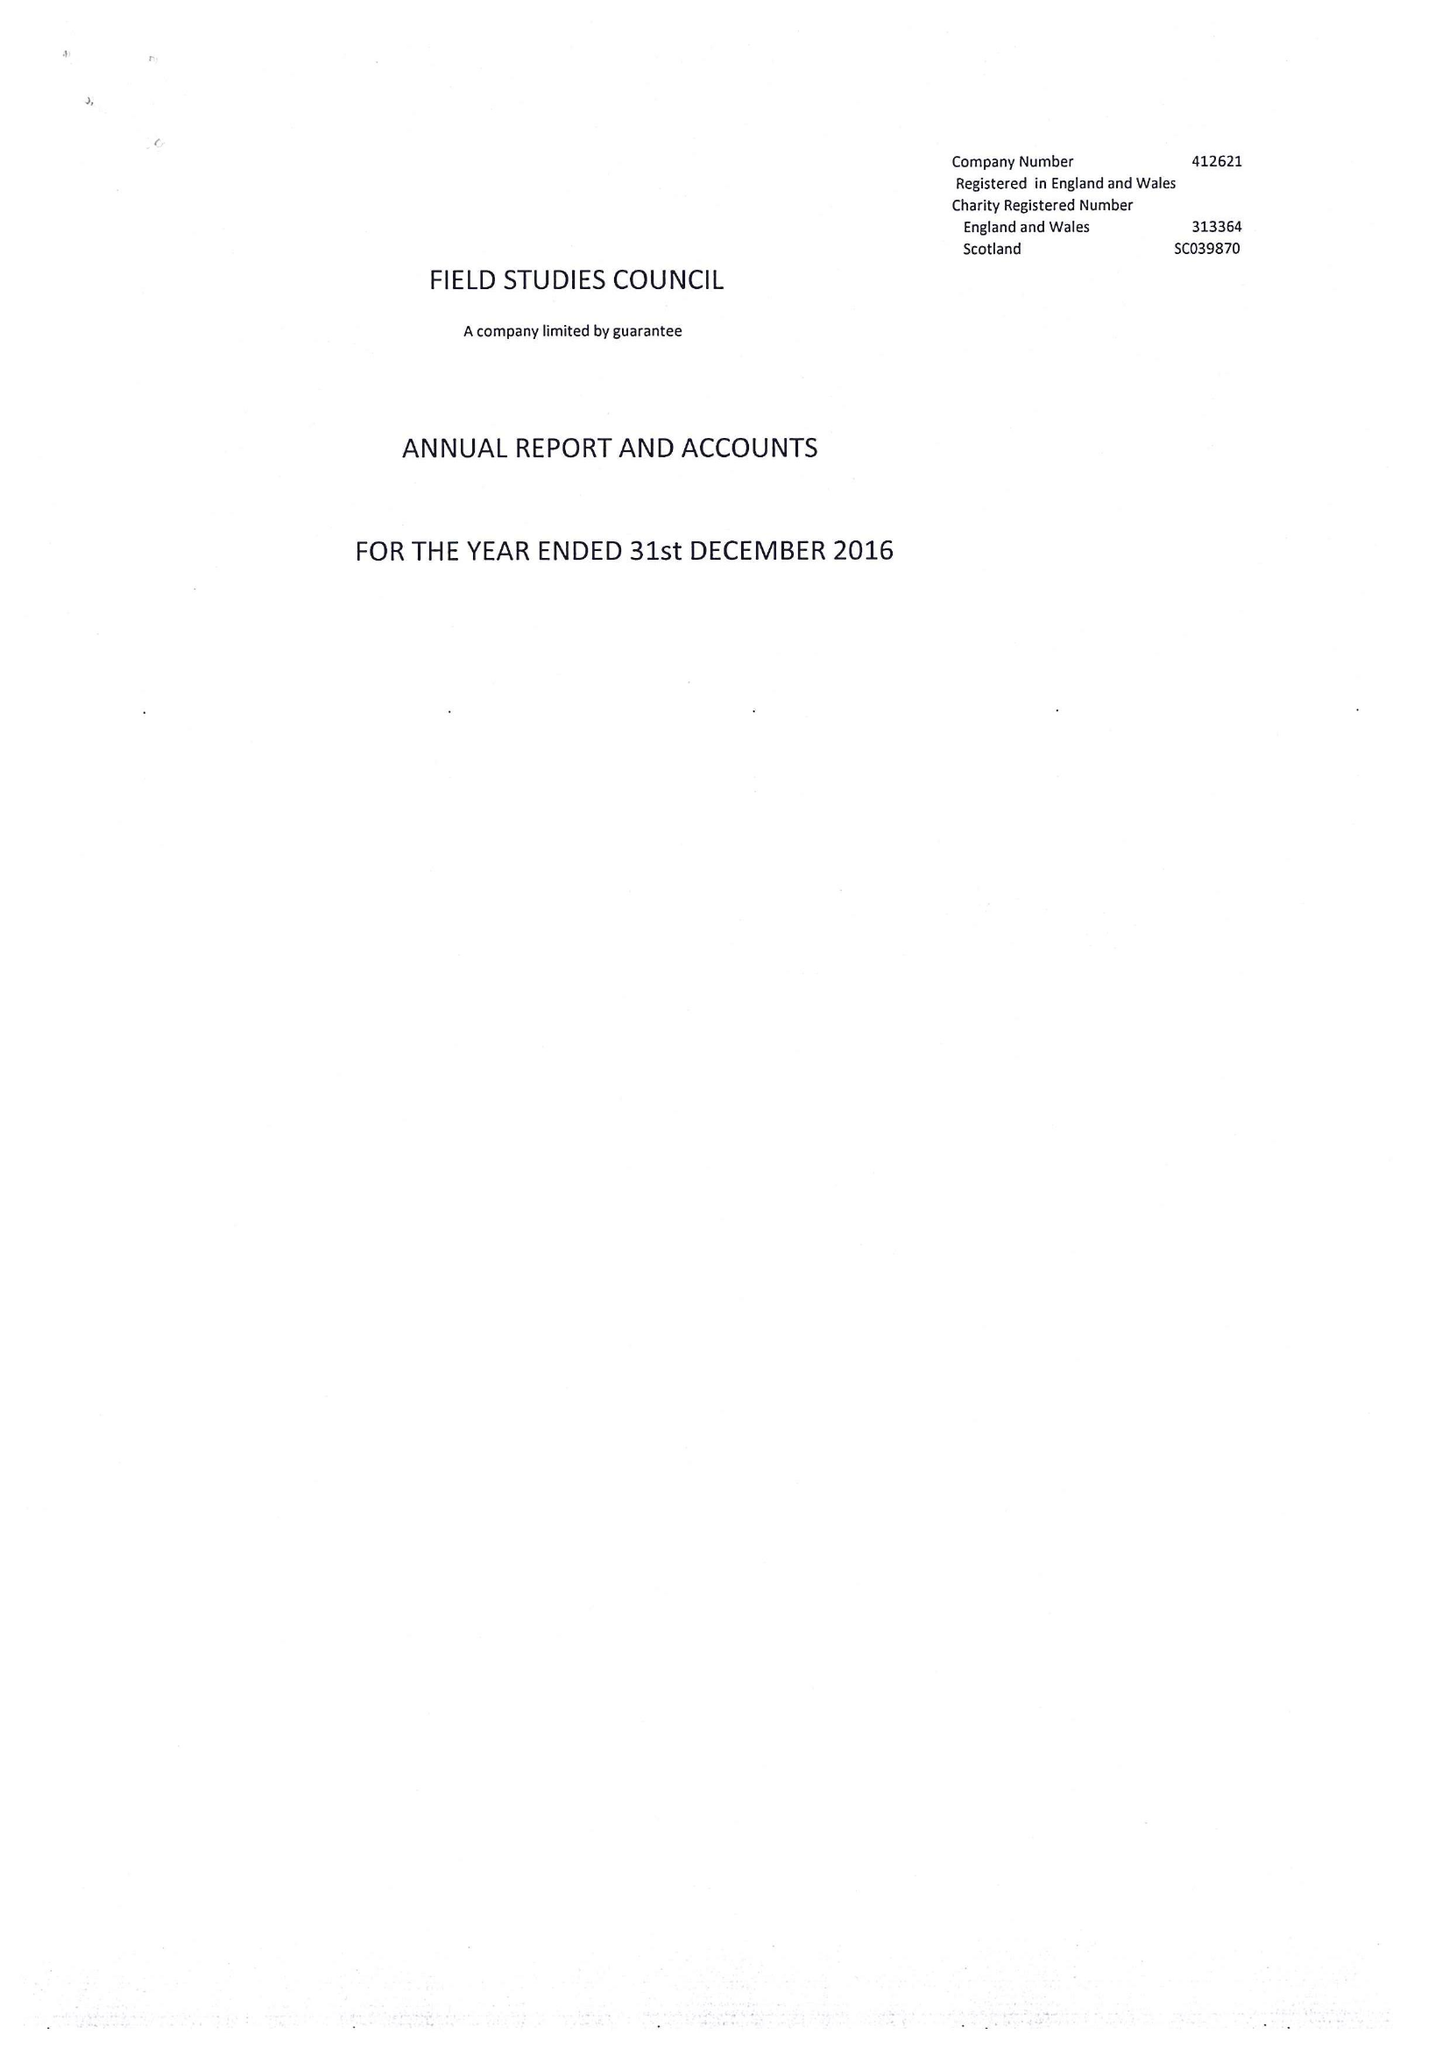What is the value for the charity_name?
Answer the question using a single word or phrase. Field Studies Council 